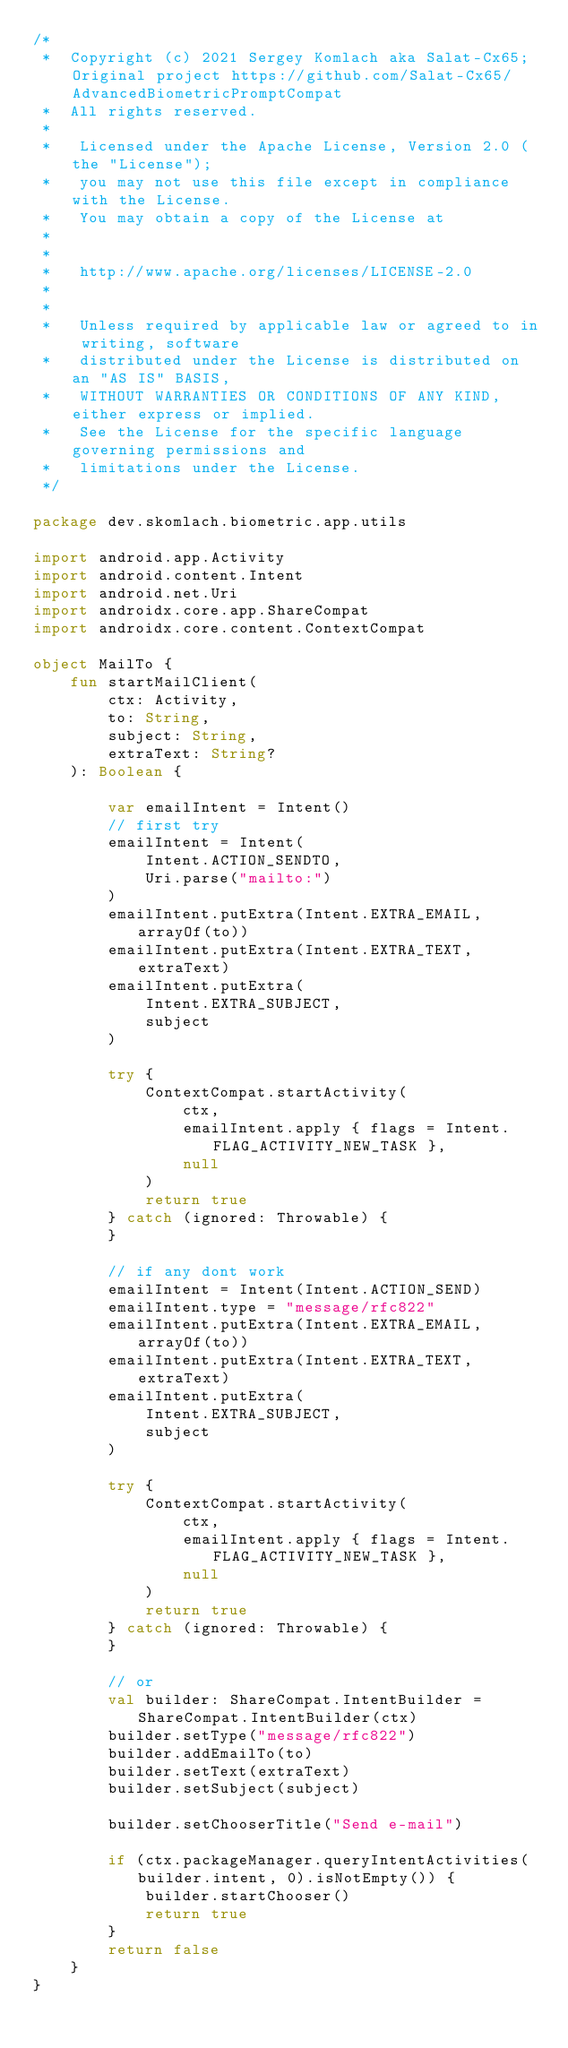<code> <loc_0><loc_0><loc_500><loc_500><_Kotlin_>/*
 *  Copyright (c) 2021 Sergey Komlach aka Salat-Cx65; Original project https://github.com/Salat-Cx65/AdvancedBiometricPromptCompat
 *  All rights reserved.
 *
 *   Licensed under the Apache License, Version 2.0 (the "License");
 *   you may not use this file except in compliance with the License.
 *   You may obtain a copy of the License at
 *
 *
 *   http://www.apache.org/licenses/LICENSE-2.0
 *
 *
 *   Unless required by applicable law or agreed to in writing, software
 *   distributed under the License is distributed on an "AS IS" BASIS,
 *   WITHOUT WARRANTIES OR CONDITIONS OF ANY KIND, either express or implied.
 *   See the License for the specific language governing permissions and
 *   limitations under the License.
 */

package dev.skomlach.biometric.app.utils

import android.app.Activity
import android.content.Intent
import android.net.Uri
import androidx.core.app.ShareCompat
import androidx.core.content.ContextCompat

object MailTo {
    fun startMailClient(
        ctx: Activity,
        to: String,
        subject: String,
        extraText: String?
    ): Boolean {

        var emailIntent = Intent()
        // first try
        emailIntent = Intent(
            Intent.ACTION_SENDTO,
            Uri.parse("mailto:")
        )
        emailIntent.putExtra(Intent.EXTRA_EMAIL, arrayOf(to))
        emailIntent.putExtra(Intent.EXTRA_TEXT, extraText)
        emailIntent.putExtra(
            Intent.EXTRA_SUBJECT,
            subject
        )

        try {
            ContextCompat.startActivity(
                ctx,
                emailIntent.apply { flags = Intent.FLAG_ACTIVITY_NEW_TASK },
                null
            )
            return true
        } catch (ignored: Throwable) {
        }

        // if any dont work
        emailIntent = Intent(Intent.ACTION_SEND)
        emailIntent.type = "message/rfc822"
        emailIntent.putExtra(Intent.EXTRA_EMAIL, arrayOf(to))
        emailIntent.putExtra(Intent.EXTRA_TEXT, extraText)
        emailIntent.putExtra(
            Intent.EXTRA_SUBJECT,
            subject
        )

        try {
            ContextCompat.startActivity(
                ctx,
                emailIntent.apply { flags = Intent.FLAG_ACTIVITY_NEW_TASK },
                null
            )
            return true
        } catch (ignored: Throwable) {
        }

        // or
        val builder: ShareCompat.IntentBuilder = ShareCompat.IntentBuilder(ctx)
        builder.setType("message/rfc822")
        builder.addEmailTo(to)
        builder.setText(extraText)
        builder.setSubject(subject)

        builder.setChooserTitle("Send e-mail")

        if (ctx.packageManager.queryIntentActivities(builder.intent, 0).isNotEmpty()) {
            builder.startChooser()
            return true
        }
        return false
    }
}</code> 